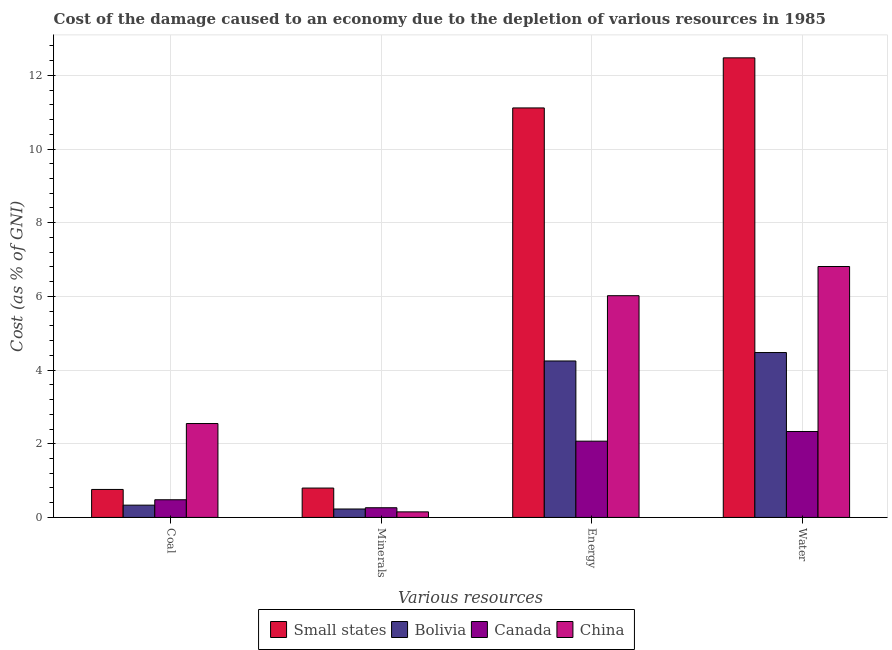Are the number of bars per tick equal to the number of legend labels?
Ensure brevity in your answer.  Yes. What is the label of the 1st group of bars from the left?
Ensure brevity in your answer.  Coal. What is the cost of damage due to depletion of minerals in China?
Provide a short and direct response. 0.15. Across all countries, what is the maximum cost of damage due to depletion of energy?
Offer a terse response. 11.12. Across all countries, what is the minimum cost of damage due to depletion of coal?
Give a very brief answer. 0.33. In which country was the cost of damage due to depletion of energy maximum?
Give a very brief answer. Small states. In which country was the cost of damage due to depletion of minerals minimum?
Provide a short and direct response. China. What is the total cost of damage due to depletion of water in the graph?
Provide a succinct answer. 26.09. What is the difference between the cost of damage due to depletion of minerals in Canada and that in Bolivia?
Your answer should be compact. 0.03. What is the difference between the cost of damage due to depletion of minerals in Canada and the cost of damage due to depletion of energy in Bolivia?
Provide a succinct answer. -3.98. What is the average cost of damage due to depletion of coal per country?
Keep it short and to the point. 1.03. What is the difference between the cost of damage due to depletion of water and cost of damage due to depletion of energy in Small states?
Keep it short and to the point. 1.36. In how many countries, is the cost of damage due to depletion of coal greater than 8.4 %?
Ensure brevity in your answer.  0. What is the ratio of the cost of damage due to depletion of energy in Bolivia to that in Canada?
Ensure brevity in your answer.  2.05. Is the difference between the cost of damage due to depletion of coal in Small states and Bolivia greater than the difference between the cost of damage due to depletion of energy in Small states and Bolivia?
Keep it short and to the point. No. What is the difference between the highest and the second highest cost of damage due to depletion of coal?
Offer a very short reply. 1.79. What is the difference between the highest and the lowest cost of damage due to depletion of minerals?
Provide a succinct answer. 0.65. Is the sum of the cost of damage due to depletion of energy in China and Canada greater than the maximum cost of damage due to depletion of minerals across all countries?
Provide a succinct answer. Yes. Is it the case that in every country, the sum of the cost of damage due to depletion of energy and cost of damage due to depletion of minerals is greater than the sum of cost of damage due to depletion of coal and cost of damage due to depletion of water?
Your answer should be very brief. No. What does the 2nd bar from the left in Water represents?
Give a very brief answer. Bolivia. What does the 2nd bar from the right in Energy represents?
Give a very brief answer. Canada. Is it the case that in every country, the sum of the cost of damage due to depletion of coal and cost of damage due to depletion of minerals is greater than the cost of damage due to depletion of energy?
Give a very brief answer. No. How many bars are there?
Give a very brief answer. 16. Are all the bars in the graph horizontal?
Give a very brief answer. No. Does the graph contain grids?
Ensure brevity in your answer.  Yes. What is the title of the graph?
Provide a succinct answer. Cost of the damage caused to an economy due to the depletion of various resources in 1985 . What is the label or title of the X-axis?
Offer a terse response. Various resources. What is the label or title of the Y-axis?
Offer a very short reply. Cost (as % of GNI). What is the Cost (as % of GNI) in Small states in Coal?
Give a very brief answer. 0.76. What is the Cost (as % of GNI) of Bolivia in Coal?
Your answer should be very brief. 0.33. What is the Cost (as % of GNI) in Canada in Coal?
Offer a very short reply. 0.48. What is the Cost (as % of GNI) in China in Coal?
Ensure brevity in your answer.  2.55. What is the Cost (as % of GNI) in Small states in Minerals?
Make the answer very short. 0.8. What is the Cost (as % of GNI) in Bolivia in Minerals?
Offer a very short reply. 0.23. What is the Cost (as % of GNI) in Canada in Minerals?
Your response must be concise. 0.26. What is the Cost (as % of GNI) of China in Minerals?
Provide a short and direct response. 0.15. What is the Cost (as % of GNI) in Small states in Energy?
Your response must be concise. 11.12. What is the Cost (as % of GNI) in Bolivia in Energy?
Give a very brief answer. 4.25. What is the Cost (as % of GNI) of Canada in Energy?
Provide a short and direct response. 2.07. What is the Cost (as % of GNI) of China in Energy?
Give a very brief answer. 6.02. What is the Cost (as % of GNI) in Small states in Water?
Give a very brief answer. 12.47. What is the Cost (as % of GNI) in Bolivia in Water?
Make the answer very short. 4.48. What is the Cost (as % of GNI) in Canada in Water?
Your response must be concise. 2.33. What is the Cost (as % of GNI) in China in Water?
Provide a short and direct response. 6.81. Across all Various resources, what is the maximum Cost (as % of GNI) in Small states?
Your response must be concise. 12.47. Across all Various resources, what is the maximum Cost (as % of GNI) in Bolivia?
Offer a very short reply. 4.48. Across all Various resources, what is the maximum Cost (as % of GNI) in Canada?
Keep it short and to the point. 2.33. Across all Various resources, what is the maximum Cost (as % of GNI) in China?
Offer a terse response. 6.81. Across all Various resources, what is the minimum Cost (as % of GNI) in Small states?
Ensure brevity in your answer.  0.76. Across all Various resources, what is the minimum Cost (as % of GNI) in Bolivia?
Your answer should be compact. 0.23. Across all Various resources, what is the minimum Cost (as % of GNI) in Canada?
Your answer should be very brief. 0.26. Across all Various resources, what is the minimum Cost (as % of GNI) of China?
Ensure brevity in your answer.  0.15. What is the total Cost (as % of GNI) in Small states in the graph?
Provide a succinct answer. 25.15. What is the total Cost (as % of GNI) in Bolivia in the graph?
Offer a very short reply. 9.28. What is the total Cost (as % of GNI) of Canada in the graph?
Ensure brevity in your answer.  5.14. What is the total Cost (as % of GNI) in China in the graph?
Your answer should be compact. 15.53. What is the difference between the Cost (as % of GNI) of Small states in Coal and that in Minerals?
Offer a terse response. -0.04. What is the difference between the Cost (as % of GNI) in Bolivia in Coal and that in Minerals?
Give a very brief answer. 0.1. What is the difference between the Cost (as % of GNI) in Canada in Coal and that in Minerals?
Give a very brief answer. 0.22. What is the difference between the Cost (as % of GNI) in China in Coal and that in Minerals?
Offer a terse response. 2.4. What is the difference between the Cost (as % of GNI) in Small states in Coal and that in Energy?
Offer a terse response. -10.36. What is the difference between the Cost (as % of GNI) of Bolivia in Coal and that in Energy?
Offer a terse response. -3.91. What is the difference between the Cost (as % of GNI) of Canada in Coal and that in Energy?
Give a very brief answer. -1.59. What is the difference between the Cost (as % of GNI) of China in Coal and that in Energy?
Keep it short and to the point. -3.47. What is the difference between the Cost (as % of GNI) of Small states in Coal and that in Water?
Offer a terse response. -11.72. What is the difference between the Cost (as % of GNI) of Bolivia in Coal and that in Water?
Your answer should be very brief. -4.14. What is the difference between the Cost (as % of GNI) of Canada in Coal and that in Water?
Offer a terse response. -1.85. What is the difference between the Cost (as % of GNI) of China in Coal and that in Water?
Provide a succinct answer. -4.26. What is the difference between the Cost (as % of GNI) in Small states in Minerals and that in Energy?
Ensure brevity in your answer.  -10.32. What is the difference between the Cost (as % of GNI) of Bolivia in Minerals and that in Energy?
Provide a short and direct response. -4.02. What is the difference between the Cost (as % of GNI) in Canada in Minerals and that in Energy?
Give a very brief answer. -1.81. What is the difference between the Cost (as % of GNI) in China in Minerals and that in Energy?
Ensure brevity in your answer.  -5.87. What is the difference between the Cost (as % of GNI) in Small states in Minerals and that in Water?
Provide a succinct answer. -11.68. What is the difference between the Cost (as % of GNI) in Bolivia in Minerals and that in Water?
Your answer should be very brief. -4.25. What is the difference between the Cost (as % of GNI) in Canada in Minerals and that in Water?
Provide a succinct answer. -2.07. What is the difference between the Cost (as % of GNI) of China in Minerals and that in Water?
Offer a very short reply. -6.66. What is the difference between the Cost (as % of GNI) in Small states in Energy and that in Water?
Offer a terse response. -1.36. What is the difference between the Cost (as % of GNI) in Bolivia in Energy and that in Water?
Ensure brevity in your answer.  -0.23. What is the difference between the Cost (as % of GNI) of Canada in Energy and that in Water?
Give a very brief answer. -0.26. What is the difference between the Cost (as % of GNI) of China in Energy and that in Water?
Your response must be concise. -0.79. What is the difference between the Cost (as % of GNI) of Small states in Coal and the Cost (as % of GNI) of Bolivia in Minerals?
Give a very brief answer. 0.53. What is the difference between the Cost (as % of GNI) in Small states in Coal and the Cost (as % of GNI) in Canada in Minerals?
Provide a short and direct response. 0.5. What is the difference between the Cost (as % of GNI) in Small states in Coal and the Cost (as % of GNI) in China in Minerals?
Give a very brief answer. 0.61. What is the difference between the Cost (as % of GNI) of Bolivia in Coal and the Cost (as % of GNI) of Canada in Minerals?
Ensure brevity in your answer.  0.07. What is the difference between the Cost (as % of GNI) in Bolivia in Coal and the Cost (as % of GNI) in China in Minerals?
Your answer should be compact. 0.18. What is the difference between the Cost (as % of GNI) of Canada in Coal and the Cost (as % of GNI) of China in Minerals?
Make the answer very short. 0.33. What is the difference between the Cost (as % of GNI) of Small states in Coal and the Cost (as % of GNI) of Bolivia in Energy?
Your answer should be very brief. -3.49. What is the difference between the Cost (as % of GNI) of Small states in Coal and the Cost (as % of GNI) of Canada in Energy?
Your response must be concise. -1.31. What is the difference between the Cost (as % of GNI) in Small states in Coal and the Cost (as % of GNI) in China in Energy?
Make the answer very short. -5.26. What is the difference between the Cost (as % of GNI) in Bolivia in Coal and the Cost (as % of GNI) in Canada in Energy?
Offer a terse response. -1.74. What is the difference between the Cost (as % of GNI) of Bolivia in Coal and the Cost (as % of GNI) of China in Energy?
Provide a succinct answer. -5.69. What is the difference between the Cost (as % of GNI) in Canada in Coal and the Cost (as % of GNI) in China in Energy?
Give a very brief answer. -5.54. What is the difference between the Cost (as % of GNI) in Small states in Coal and the Cost (as % of GNI) in Bolivia in Water?
Keep it short and to the point. -3.72. What is the difference between the Cost (as % of GNI) in Small states in Coal and the Cost (as % of GNI) in Canada in Water?
Provide a succinct answer. -1.57. What is the difference between the Cost (as % of GNI) of Small states in Coal and the Cost (as % of GNI) of China in Water?
Provide a succinct answer. -6.05. What is the difference between the Cost (as % of GNI) of Bolivia in Coal and the Cost (as % of GNI) of Canada in Water?
Provide a short and direct response. -2. What is the difference between the Cost (as % of GNI) of Bolivia in Coal and the Cost (as % of GNI) of China in Water?
Keep it short and to the point. -6.48. What is the difference between the Cost (as % of GNI) in Canada in Coal and the Cost (as % of GNI) in China in Water?
Your answer should be very brief. -6.33. What is the difference between the Cost (as % of GNI) in Small states in Minerals and the Cost (as % of GNI) in Bolivia in Energy?
Provide a short and direct response. -3.45. What is the difference between the Cost (as % of GNI) of Small states in Minerals and the Cost (as % of GNI) of Canada in Energy?
Your answer should be very brief. -1.27. What is the difference between the Cost (as % of GNI) in Small states in Minerals and the Cost (as % of GNI) in China in Energy?
Your response must be concise. -5.22. What is the difference between the Cost (as % of GNI) in Bolivia in Minerals and the Cost (as % of GNI) in Canada in Energy?
Give a very brief answer. -1.84. What is the difference between the Cost (as % of GNI) in Bolivia in Minerals and the Cost (as % of GNI) in China in Energy?
Offer a terse response. -5.79. What is the difference between the Cost (as % of GNI) in Canada in Minerals and the Cost (as % of GNI) in China in Energy?
Ensure brevity in your answer.  -5.76. What is the difference between the Cost (as % of GNI) of Small states in Minerals and the Cost (as % of GNI) of Bolivia in Water?
Keep it short and to the point. -3.68. What is the difference between the Cost (as % of GNI) of Small states in Minerals and the Cost (as % of GNI) of Canada in Water?
Ensure brevity in your answer.  -1.54. What is the difference between the Cost (as % of GNI) in Small states in Minerals and the Cost (as % of GNI) in China in Water?
Provide a succinct answer. -6.01. What is the difference between the Cost (as % of GNI) of Bolivia in Minerals and the Cost (as % of GNI) of Canada in Water?
Offer a terse response. -2.1. What is the difference between the Cost (as % of GNI) of Bolivia in Minerals and the Cost (as % of GNI) of China in Water?
Offer a terse response. -6.58. What is the difference between the Cost (as % of GNI) of Canada in Minerals and the Cost (as % of GNI) of China in Water?
Your answer should be very brief. -6.55. What is the difference between the Cost (as % of GNI) of Small states in Energy and the Cost (as % of GNI) of Bolivia in Water?
Your answer should be compact. 6.64. What is the difference between the Cost (as % of GNI) in Small states in Energy and the Cost (as % of GNI) in Canada in Water?
Give a very brief answer. 8.78. What is the difference between the Cost (as % of GNI) in Small states in Energy and the Cost (as % of GNI) in China in Water?
Your response must be concise. 4.3. What is the difference between the Cost (as % of GNI) in Bolivia in Energy and the Cost (as % of GNI) in Canada in Water?
Give a very brief answer. 1.91. What is the difference between the Cost (as % of GNI) of Bolivia in Energy and the Cost (as % of GNI) of China in Water?
Your answer should be very brief. -2.56. What is the difference between the Cost (as % of GNI) in Canada in Energy and the Cost (as % of GNI) in China in Water?
Keep it short and to the point. -4.74. What is the average Cost (as % of GNI) of Small states per Various resources?
Offer a very short reply. 6.29. What is the average Cost (as % of GNI) of Bolivia per Various resources?
Offer a very short reply. 2.32. What is the average Cost (as % of GNI) in Canada per Various resources?
Your response must be concise. 1.29. What is the average Cost (as % of GNI) of China per Various resources?
Ensure brevity in your answer.  3.88. What is the difference between the Cost (as % of GNI) in Small states and Cost (as % of GNI) in Bolivia in Coal?
Offer a very short reply. 0.43. What is the difference between the Cost (as % of GNI) of Small states and Cost (as % of GNI) of Canada in Coal?
Make the answer very short. 0.28. What is the difference between the Cost (as % of GNI) in Small states and Cost (as % of GNI) in China in Coal?
Provide a succinct answer. -1.79. What is the difference between the Cost (as % of GNI) in Bolivia and Cost (as % of GNI) in Canada in Coal?
Ensure brevity in your answer.  -0.15. What is the difference between the Cost (as % of GNI) of Bolivia and Cost (as % of GNI) of China in Coal?
Give a very brief answer. -2.22. What is the difference between the Cost (as % of GNI) in Canada and Cost (as % of GNI) in China in Coal?
Offer a terse response. -2.07. What is the difference between the Cost (as % of GNI) of Small states and Cost (as % of GNI) of Bolivia in Minerals?
Offer a very short reply. 0.57. What is the difference between the Cost (as % of GNI) in Small states and Cost (as % of GNI) in Canada in Minerals?
Offer a very short reply. 0.53. What is the difference between the Cost (as % of GNI) in Small states and Cost (as % of GNI) in China in Minerals?
Ensure brevity in your answer.  0.65. What is the difference between the Cost (as % of GNI) in Bolivia and Cost (as % of GNI) in Canada in Minerals?
Provide a short and direct response. -0.03. What is the difference between the Cost (as % of GNI) in Bolivia and Cost (as % of GNI) in China in Minerals?
Provide a succinct answer. 0.08. What is the difference between the Cost (as % of GNI) in Canada and Cost (as % of GNI) in China in Minerals?
Make the answer very short. 0.11. What is the difference between the Cost (as % of GNI) in Small states and Cost (as % of GNI) in Bolivia in Energy?
Give a very brief answer. 6.87. What is the difference between the Cost (as % of GNI) of Small states and Cost (as % of GNI) of Canada in Energy?
Keep it short and to the point. 9.05. What is the difference between the Cost (as % of GNI) of Small states and Cost (as % of GNI) of China in Energy?
Offer a very short reply. 5.1. What is the difference between the Cost (as % of GNI) in Bolivia and Cost (as % of GNI) in Canada in Energy?
Ensure brevity in your answer.  2.18. What is the difference between the Cost (as % of GNI) of Bolivia and Cost (as % of GNI) of China in Energy?
Your answer should be very brief. -1.77. What is the difference between the Cost (as % of GNI) of Canada and Cost (as % of GNI) of China in Energy?
Your response must be concise. -3.95. What is the difference between the Cost (as % of GNI) of Small states and Cost (as % of GNI) of Bolivia in Water?
Keep it short and to the point. 8. What is the difference between the Cost (as % of GNI) of Small states and Cost (as % of GNI) of Canada in Water?
Provide a succinct answer. 10.14. What is the difference between the Cost (as % of GNI) in Small states and Cost (as % of GNI) in China in Water?
Your answer should be compact. 5.66. What is the difference between the Cost (as % of GNI) in Bolivia and Cost (as % of GNI) in Canada in Water?
Your response must be concise. 2.14. What is the difference between the Cost (as % of GNI) in Bolivia and Cost (as % of GNI) in China in Water?
Your response must be concise. -2.34. What is the difference between the Cost (as % of GNI) in Canada and Cost (as % of GNI) in China in Water?
Your response must be concise. -4.48. What is the ratio of the Cost (as % of GNI) of Small states in Coal to that in Minerals?
Keep it short and to the point. 0.95. What is the ratio of the Cost (as % of GNI) of Bolivia in Coal to that in Minerals?
Keep it short and to the point. 1.45. What is the ratio of the Cost (as % of GNI) of Canada in Coal to that in Minerals?
Provide a succinct answer. 1.82. What is the ratio of the Cost (as % of GNI) of China in Coal to that in Minerals?
Your answer should be compact. 16.91. What is the ratio of the Cost (as % of GNI) of Small states in Coal to that in Energy?
Provide a short and direct response. 0.07. What is the ratio of the Cost (as % of GNI) in Bolivia in Coal to that in Energy?
Ensure brevity in your answer.  0.08. What is the ratio of the Cost (as % of GNI) in Canada in Coal to that in Energy?
Your response must be concise. 0.23. What is the ratio of the Cost (as % of GNI) in China in Coal to that in Energy?
Your answer should be very brief. 0.42. What is the ratio of the Cost (as % of GNI) in Small states in Coal to that in Water?
Offer a very short reply. 0.06. What is the ratio of the Cost (as % of GNI) in Bolivia in Coal to that in Water?
Provide a succinct answer. 0.07. What is the ratio of the Cost (as % of GNI) in Canada in Coal to that in Water?
Your response must be concise. 0.21. What is the ratio of the Cost (as % of GNI) in China in Coal to that in Water?
Provide a succinct answer. 0.37. What is the ratio of the Cost (as % of GNI) in Small states in Minerals to that in Energy?
Make the answer very short. 0.07. What is the ratio of the Cost (as % of GNI) of Bolivia in Minerals to that in Energy?
Offer a terse response. 0.05. What is the ratio of the Cost (as % of GNI) of Canada in Minerals to that in Energy?
Your answer should be very brief. 0.13. What is the ratio of the Cost (as % of GNI) in China in Minerals to that in Energy?
Provide a short and direct response. 0.03. What is the ratio of the Cost (as % of GNI) of Small states in Minerals to that in Water?
Your response must be concise. 0.06. What is the ratio of the Cost (as % of GNI) of Bolivia in Minerals to that in Water?
Keep it short and to the point. 0.05. What is the ratio of the Cost (as % of GNI) of Canada in Minerals to that in Water?
Provide a short and direct response. 0.11. What is the ratio of the Cost (as % of GNI) in China in Minerals to that in Water?
Make the answer very short. 0.02. What is the ratio of the Cost (as % of GNI) of Small states in Energy to that in Water?
Give a very brief answer. 0.89. What is the ratio of the Cost (as % of GNI) of Bolivia in Energy to that in Water?
Your answer should be very brief. 0.95. What is the ratio of the Cost (as % of GNI) in Canada in Energy to that in Water?
Offer a terse response. 0.89. What is the ratio of the Cost (as % of GNI) of China in Energy to that in Water?
Your response must be concise. 0.88. What is the difference between the highest and the second highest Cost (as % of GNI) in Small states?
Provide a short and direct response. 1.36. What is the difference between the highest and the second highest Cost (as % of GNI) in Bolivia?
Offer a very short reply. 0.23. What is the difference between the highest and the second highest Cost (as % of GNI) in Canada?
Provide a short and direct response. 0.26. What is the difference between the highest and the second highest Cost (as % of GNI) of China?
Ensure brevity in your answer.  0.79. What is the difference between the highest and the lowest Cost (as % of GNI) in Small states?
Offer a very short reply. 11.72. What is the difference between the highest and the lowest Cost (as % of GNI) of Bolivia?
Offer a very short reply. 4.25. What is the difference between the highest and the lowest Cost (as % of GNI) in Canada?
Provide a succinct answer. 2.07. What is the difference between the highest and the lowest Cost (as % of GNI) of China?
Your answer should be compact. 6.66. 